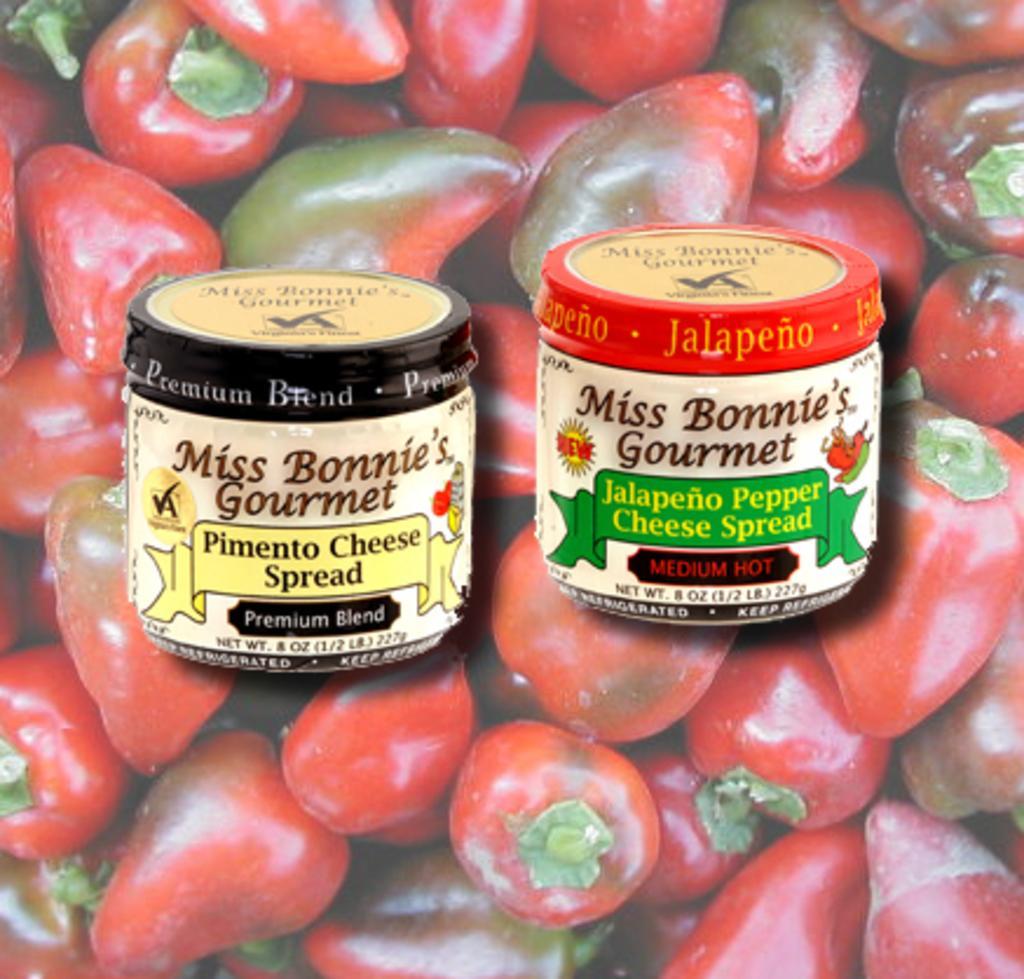How would you summarize this image in a sentence or two? This is an edited image. We can see two objects. Behind the objects there are chillies. 